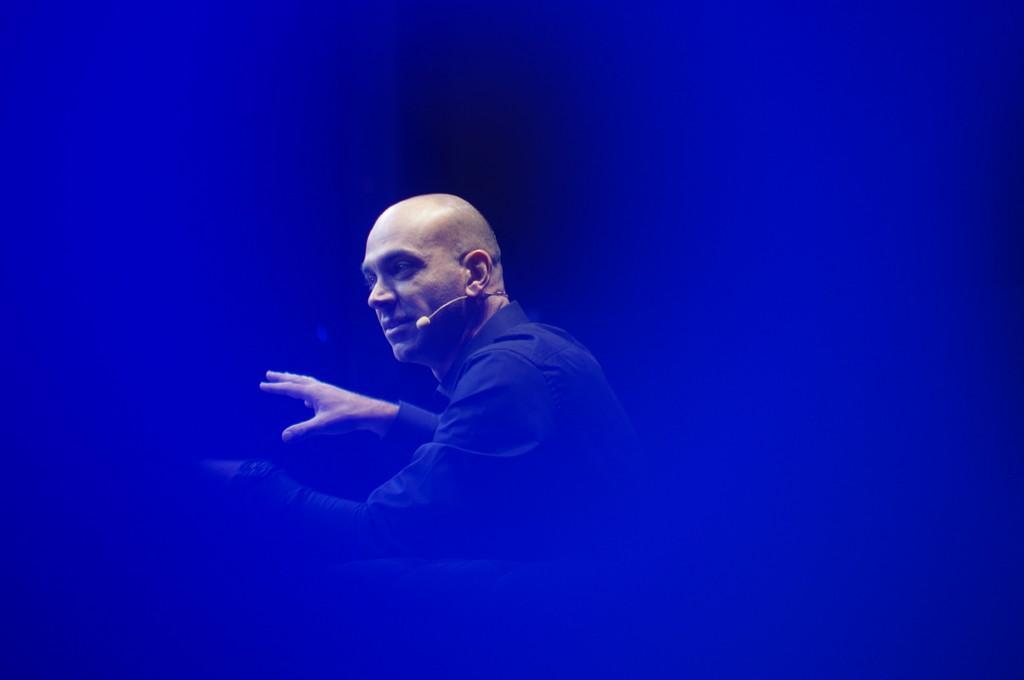Can you describe this image briefly? In this image I can see a person facing towards the left wearing mike and the background is blurred. 